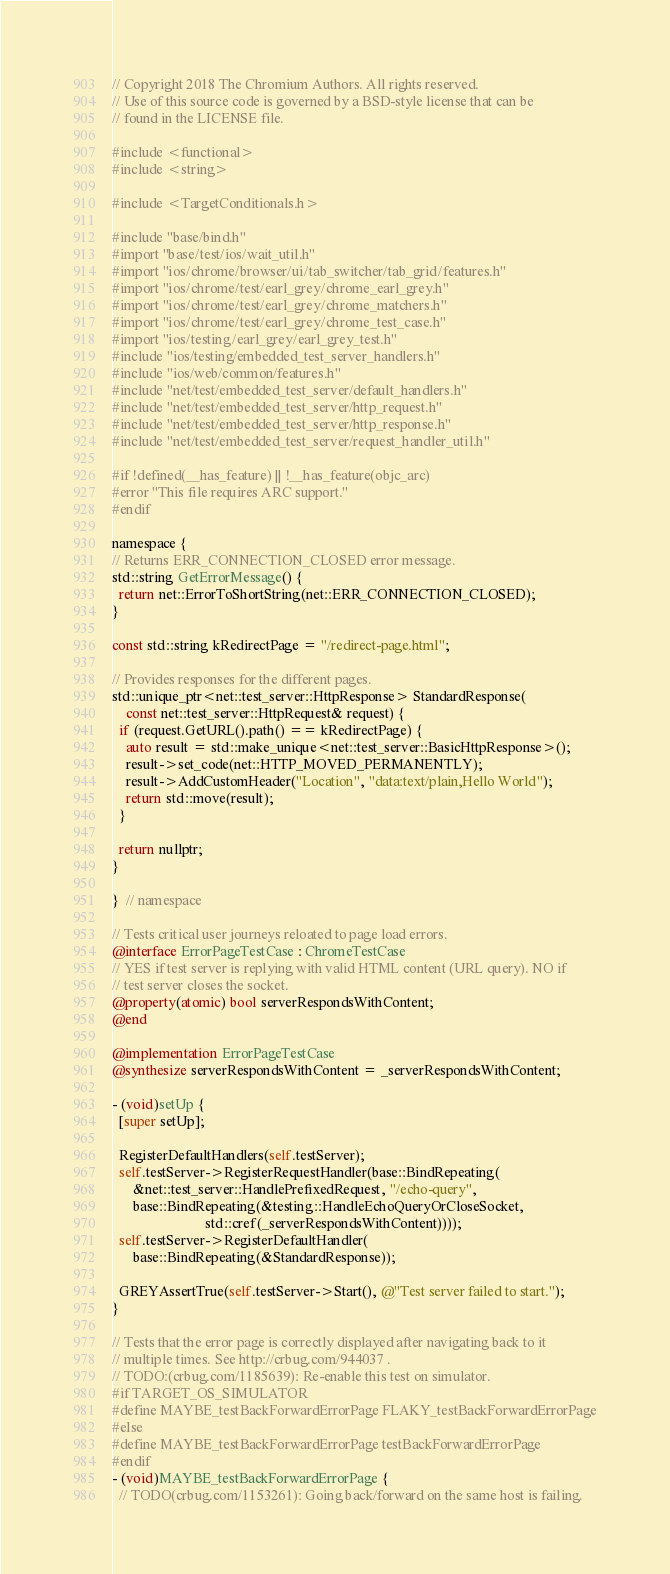Convert code to text. <code><loc_0><loc_0><loc_500><loc_500><_ObjectiveC_>// Copyright 2018 The Chromium Authors. All rights reserved.
// Use of this source code is governed by a BSD-style license that can be
// found in the LICENSE file.

#include <functional>
#include <string>

#include <TargetConditionals.h>

#include "base/bind.h"
#import "base/test/ios/wait_util.h"
#import "ios/chrome/browser/ui/tab_switcher/tab_grid/features.h"
#import "ios/chrome/test/earl_grey/chrome_earl_grey.h"
#import "ios/chrome/test/earl_grey/chrome_matchers.h"
#import "ios/chrome/test/earl_grey/chrome_test_case.h"
#import "ios/testing/earl_grey/earl_grey_test.h"
#include "ios/testing/embedded_test_server_handlers.h"
#include "ios/web/common/features.h"
#include "net/test/embedded_test_server/default_handlers.h"
#include "net/test/embedded_test_server/http_request.h"
#include "net/test/embedded_test_server/http_response.h"
#include "net/test/embedded_test_server/request_handler_util.h"

#if !defined(__has_feature) || !__has_feature(objc_arc)
#error "This file requires ARC support."
#endif

namespace {
// Returns ERR_CONNECTION_CLOSED error message.
std::string GetErrorMessage() {
  return net::ErrorToShortString(net::ERR_CONNECTION_CLOSED);
}

const std::string kRedirectPage = "/redirect-page.html";

// Provides responses for the different pages.
std::unique_ptr<net::test_server::HttpResponse> StandardResponse(
    const net::test_server::HttpRequest& request) {
  if (request.GetURL().path() == kRedirectPage) {
    auto result = std::make_unique<net::test_server::BasicHttpResponse>();
    result->set_code(net::HTTP_MOVED_PERMANENTLY);
    result->AddCustomHeader("Location", "data:text/plain,Hello World");
    return std::move(result);
  }

  return nullptr;
}

}  // namespace

// Tests critical user journeys reloated to page load errors.
@interface ErrorPageTestCase : ChromeTestCase
// YES if test server is replying with valid HTML content (URL query). NO if
// test server closes the socket.
@property(atomic) bool serverRespondsWithContent;
@end

@implementation ErrorPageTestCase
@synthesize serverRespondsWithContent = _serverRespondsWithContent;

- (void)setUp {
  [super setUp];

  RegisterDefaultHandlers(self.testServer);
  self.testServer->RegisterRequestHandler(base::BindRepeating(
      &net::test_server::HandlePrefixedRequest, "/echo-query",
      base::BindRepeating(&testing::HandleEchoQueryOrCloseSocket,
                          std::cref(_serverRespondsWithContent))));
  self.testServer->RegisterDefaultHandler(
      base::BindRepeating(&StandardResponse));

  GREYAssertTrue(self.testServer->Start(), @"Test server failed to start.");
}

// Tests that the error page is correctly displayed after navigating back to it
// multiple times. See http://crbug.com/944037 .
// TODO:(crbug.com/1185639): Re-enable this test on simulator.
#if TARGET_OS_SIMULATOR
#define MAYBE_testBackForwardErrorPage FLAKY_testBackForwardErrorPage
#else
#define MAYBE_testBackForwardErrorPage testBackForwardErrorPage
#endif
- (void)MAYBE_testBackForwardErrorPage {
  // TODO(crbug.com/1153261): Going back/forward on the same host is failing.</code> 